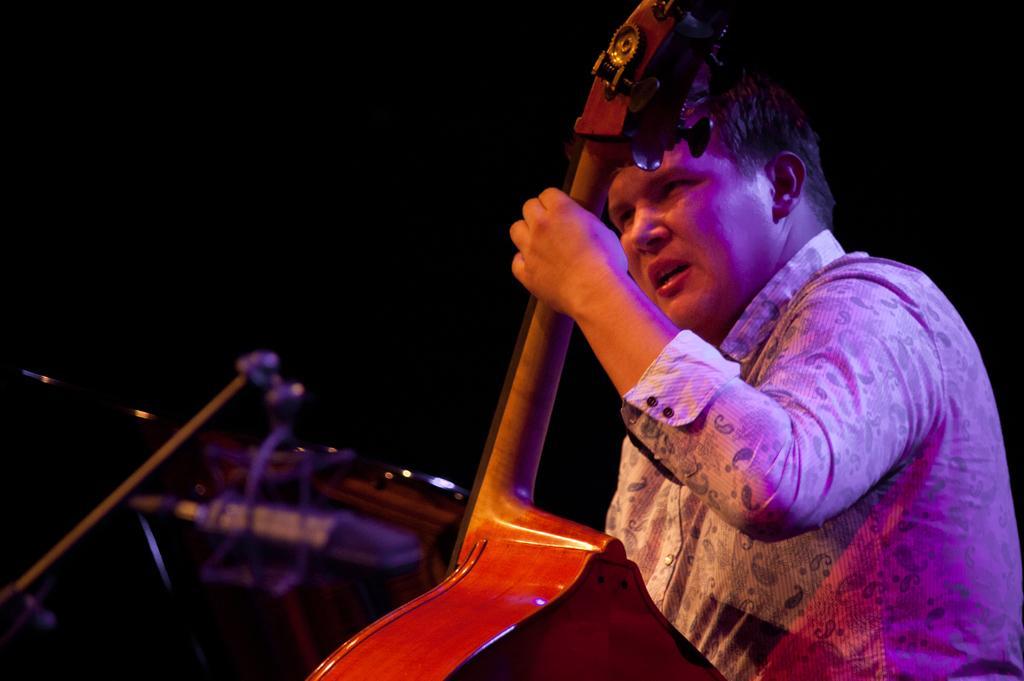Can you describe this image briefly? This man is highlighted in this picture. This man is holding a musical instrument. 